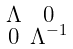<formula> <loc_0><loc_0><loc_500><loc_500>\begin{smallmatrix} \Lambda & 0 \\ 0 & \Lambda ^ { - 1 } \end{smallmatrix}</formula> 